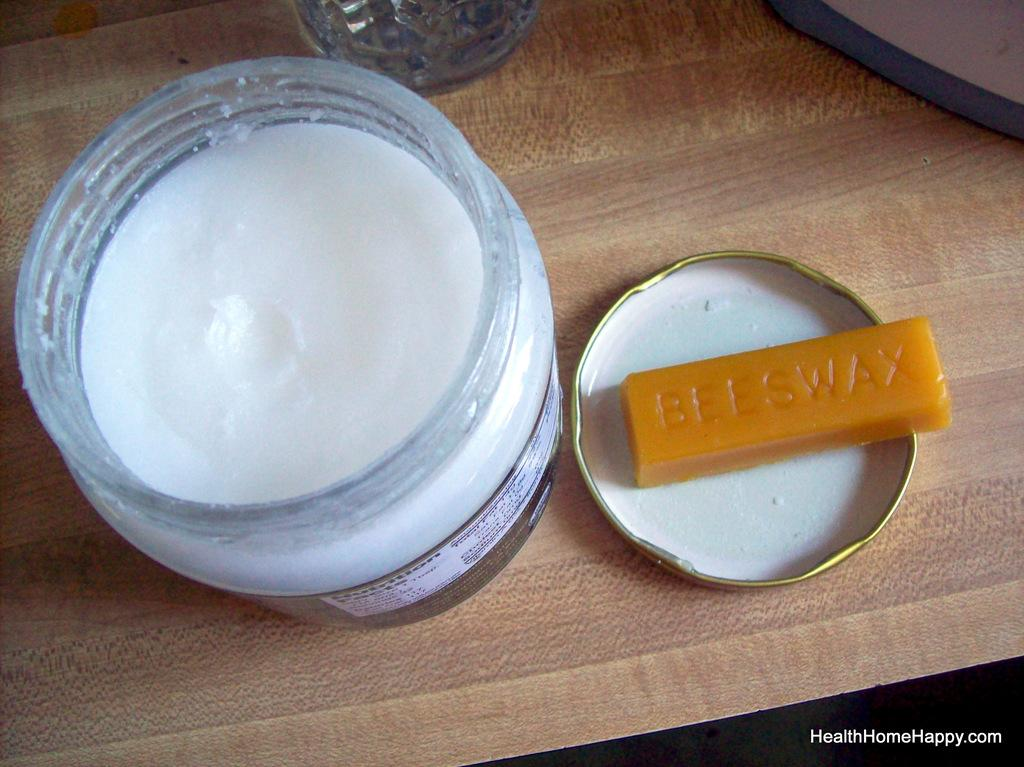What object is in the foreground of the image? There is a glass bottle in the image. What is located behind the bottle? There is a cap behind the bottle. What type of surface is visible at the bottom of the image? There is a wooden surface at the bottom of the image. Where is the text located in the image? The text is at the right bottom of the image. What time does the army march by in the image? There is no army or indication of time in the image; it only features a glass bottle, a cap, a wooden surface, and some text. 